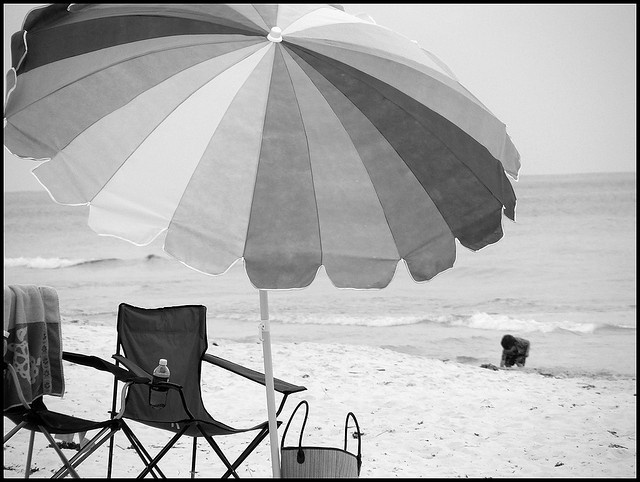Describe the objects in this image and their specific colors. I can see umbrella in black, darkgray, lightgray, and gray tones, chair in black, lightgray, gray, and darkgray tones, chair in black, lightgray, gray, and darkgray tones, handbag in black, dimgray, white, and gray tones, and people in black, gray, darkgray, and lightgray tones in this image. 